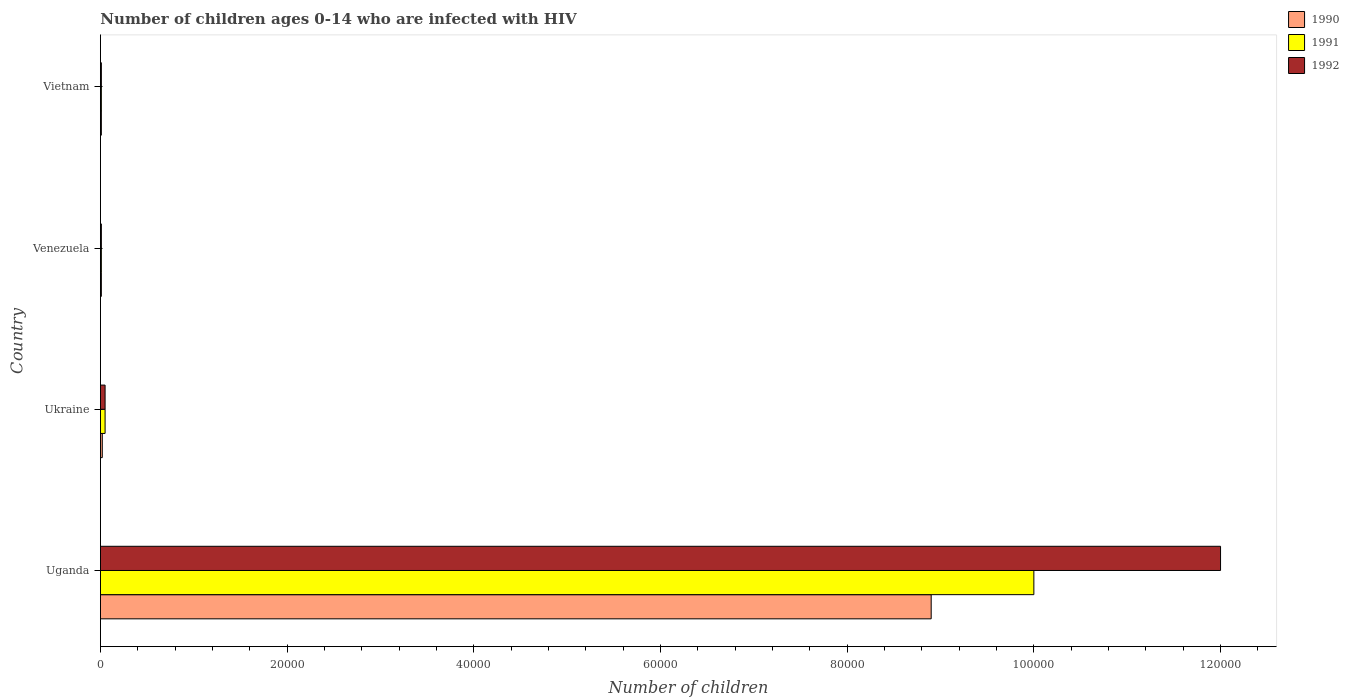How many different coloured bars are there?
Offer a very short reply. 3. Are the number of bars per tick equal to the number of legend labels?
Your response must be concise. Yes. Are the number of bars on each tick of the Y-axis equal?
Offer a very short reply. Yes. How many bars are there on the 3rd tick from the top?
Offer a very short reply. 3. What is the label of the 4th group of bars from the top?
Your answer should be compact. Uganda. What is the number of HIV infected children in 1991 in Ukraine?
Give a very brief answer. 500. Across all countries, what is the maximum number of HIV infected children in 1990?
Offer a terse response. 8.90e+04. Across all countries, what is the minimum number of HIV infected children in 1990?
Provide a short and direct response. 100. In which country was the number of HIV infected children in 1990 maximum?
Your response must be concise. Uganda. In which country was the number of HIV infected children in 1992 minimum?
Your response must be concise. Venezuela. What is the total number of HIV infected children in 1992 in the graph?
Offer a terse response. 1.21e+05. What is the difference between the number of HIV infected children in 1990 in Uganda and that in Ukraine?
Your answer should be compact. 8.88e+04. What is the difference between the number of HIV infected children in 1992 in Uganda and the number of HIV infected children in 1990 in Ukraine?
Offer a very short reply. 1.20e+05. What is the average number of HIV infected children in 1991 per country?
Make the answer very short. 2.52e+04. What is the difference between the number of HIV infected children in 1992 and number of HIV infected children in 1990 in Venezuela?
Make the answer very short. 0. In how many countries, is the number of HIV infected children in 1990 greater than 80000 ?
Offer a terse response. 1. What is the ratio of the number of HIV infected children in 1991 in Uganda to that in Ukraine?
Make the answer very short. 200. Is the number of HIV infected children in 1991 in Uganda less than that in Vietnam?
Your answer should be very brief. No. What is the difference between the highest and the second highest number of HIV infected children in 1992?
Ensure brevity in your answer.  1.20e+05. What is the difference between the highest and the lowest number of HIV infected children in 1990?
Keep it short and to the point. 8.89e+04. In how many countries, is the number of HIV infected children in 1991 greater than the average number of HIV infected children in 1991 taken over all countries?
Your answer should be very brief. 1. What does the 3rd bar from the top in Vietnam represents?
Your answer should be compact. 1990. What does the 3rd bar from the bottom in Venezuela represents?
Make the answer very short. 1992. Is it the case that in every country, the sum of the number of HIV infected children in 1992 and number of HIV infected children in 1991 is greater than the number of HIV infected children in 1990?
Your answer should be very brief. Yes. How many bars are there?
Your response must be concise. 12. Are all the bars in the graph horizontal?
Offer a terse response. Yes. How many countries are there in the graph?
Provide a succinct answer. 4. What is the difference between two consecutive major ticks on the X-axis?
Ensure brevity in your answer.  2.00e+04. Does the graph contain any zero values?
Offer a terse response. No. Where does the legend appear in the graph?
Provide a short and direct response. Top right. How many legend labels are there?
Your answer should be very brief. 3. What is the title of the graph?
Give a very brief answer. Number of children ages 0-14 who are infected with HIV. What is the label or title of the X-axis?
Make the answer very short. Number of children. What is the label or title of the Y-axis?
Make the answer very short. Country. What is the Number of children of 1990 in Uganda?
Provide a short and direct response. 8.90e+04. What is the Number of children of 1991 in Uganda?
Give a very brief answer. 1.00e+05. What is the Number of children of 1992 in Uganda?
Your response must be concise. 1.20e+05. What is the Number of children in 1990 in Ukraine?
Ensure brevity in your answer.  200. What is the Number of children in 1992 in Ukraine?
Offer a very short reply. 500. What is the Number of children in 1990 in Venezuela?
Your answer should be very brief. 100. What is the Number of children in 1991 in Venezuela?
Provide a short and direct response. 100. What is the Number of children in 1992 in Vietnam?
Keep it short and to the point. 100. Across all countries, what is the maximum Number of children of 1990?
Your answer should be compact. 8.90e+04. Across all countries, what is the minimum Number of children of 1990?
Offer a very short reply. 100. What is the total Number of children of 1990 in the graph?
Offer a terse response. 8.94e+04. What is the total Number of children in 1991 in the graph?
Your answer should be compact. 1.01e+05. What is the total Number of children of 1992 in the graph?
Provide a succinct answer. 1.21e+05. What is the difference between the Number of children in 1990 in Uganda and that in Ukraine?
Provide a short and direct response. 8.88e+04. What is the difference between the Number of children in 1991 in Uganda and that in Ukraine?
Provide a succinct answer. 9.95e+04. What is the difference between the Number of children of 1992 in Uganda and that in Ukraine?
Keep it short and to the point. 1.20e+05. What is the difference between the Number of children of 1990 in Uganda and that in Venezuela?
Your response must be concise. 8.89e+04. What is the difference between the Number of children in 1991 in Uganda and that in Venezuela?
Make the answer very short. 9.99e+04. What is the difference between the Number of children of 1992 in Uganda and that in Venezuela?
Your answer should be compact. 1.20e+05. What is the difference between the Number of children in 1990 in Uganda and that in Vietnam?
Provide a succinct answer. 8.89e+04. What is the difference between the Number of children of 1991 in Uganda and that in Vietnam?
Ensure brevity in your answer.  9.99e+04. What is the difference between the Number of children of 1992 in Uganda and that in Vietnam?
Provide a short and direct response. 1.20e+05. What is the difference between the Number of children of 1992 in Ukraine and that in Venezuela?
Offer a terse response. 400. What is the difference between the Number of children of 1992 in Ukraine and that in Vietnam?
Make the answer very short. 400. What is the difference between the Number of children of 1990 in Venezuela and that in Vietnam?
Make the answer very short. 0. What is the difference between the Number of children of 1992 in Venezuela and that in Vietnam?
Provide a succinct answer. 0. What is the difference between the Number of children of 1990 in Uganda and the Number of children of 1991 in Ukraine?
Your response must be concise. 8.85e+04. What is the difference between the Number of children in 1990 in Uganda and the Number of children in 1992 in Ukraine?
Your answer should be compact. 8.85e+04. What is the difference between the Number of children of 1991 in Uganda and the Number of children of 1992 in Ukraine?
Your answer should be very brief. 9.95e+04. What is the difference between the Number of children in 1990 in Uganda and the Number of children in 1991 in Venezuela?
Offer a very short reply. 8.89e+04. What is the difference between the Number of children of 1990 in Uganda and the Number of children of 1992 in Venezuela?
Keep it short and to the point. 8.89e+04. What is the difference between the Number of children of 1991 in Uganda and the Number of children of 1992 in Venezuela?
Offer a very short reply. 9.99e+04. What is the difference between the Number of children in 1990 in Uganda and the Number of children in 1991 in Vietnam?
Ensure brevity in your answer.  8.89e+04. What is the difference between the Number of children of 1990 in Uganda and the Number of children of 1992 in Vietnam?
Your answer should be compact. 8.89e+04. What is the difference between the Number of children in 1991 in Uganda and the Number of children in 1992 in Vietnam?
Make the answer very short. 9.99e+04. What is the difference between the Number of children of 1990 in Ukraine and the Number of children of 1991 in Venezuela?
Offer a terse response. 100. What is the difference between the Number of children in 1990 in Ukraine and the Number of children in 1991 in Vietnam?
Offer a terse response. 100. What is the difference between the Number of children in 1991 in Ukraine and the Number of children in 1992 in Vietnam?
Your answer should be very brief. 400. What is the difference between the Number of children of 1990 in Venezuela and the Number of children of 1991 in Vietnam?
Provide a short and direct response. 0. What is the average Number of children of 1990 per country?
Provide a short and direct response. 2.24e+04. What is the average Number of children in 1991 per country?
Provide a succinct answer. 2.52e+04. What is the average Number of children of 1992 per country?
Give a very brief answer. 3.02e+04. What is the difference between the Number of children in 1990 and Number of children in 1991 in Uganda?
Keep it short and to the point. -1.10e+04. What is the difference between the Number of children of 1990 and Number of children of 1992 in Uganda?
Offer a terse response. -3.10e+04. What is the difference between the Number of children of 1990 and Number of children of 1991 in Ukraine?
Keep it short and to the point. -300. What is the difference between the Number of children in 1990 and Number of children in 1992 in Ukraine?
Offer a very short reply. -300. What is the difference between the Number of children in 1990 and Number of children in 1991 in Vietnam?
Your response must be concise. 0. What is the difference between the Number of children in 1990 and Number of children in 1992 in Vietnam?
Offer a very short reply. 0. What is the ratio of the Number of children in 1990 in Uganda to that in Ukraine?
Provide a short and direct response. 445. What is the ratio of the Number of children of 1992 in Uganda to that in Ukraine?
Offer a very short reply. 240. What is the ratio of the Number of children of 1990 in Uganda to that in Venezuela?
Provide a succinct answer. 890. What is the ratio of the Number of children in 1991 in Uganda to that in Venezuela?
Keep it short and to the point. 1000. What is the ratio of the Number of children in 1992 in Uganda to that in Venezuela?
Ensure brevity in your answer.  1200. What is the ratio of the Number of children of 1990 in Uganda to that in Vietnam?
Offer a very short reply. 890. What is the ratio of the Number of children of 1991 in Uganda to that in Vietnam?
Your response must be concise. 1000. What is the ratio of the Number of children in 1992 in Uganda to that in Vietnam?
Keep it short and to the point. 1200. What is the ratio of the Number of children of 1991 in Ukraine to that in Venezuela?
Keep it short and to the point. 5. What is the ratio of the Number of children in 1992 in Ukraine to that in Venezuela?
Provide a succinct answer. 5. What is the ratio of the Number of children in 1990 in Ukraine to that in Vietnam?
Your answer should be compact. 2. What is the ratio of the Number of children of 1991 in Venezuela to that in Vietnam?
Give a very brief answer. 1. What is the ratio of the Number of children of 1992 in Venezuela to that in Vietnam?
Offer a terse response. 1. What is the difference between the highest and the second highest Number of children in 1990?
Provide a succinct answer. 8.88e+04. What is the difference between the highest and the second highest Number of children in 1991?
Make the answer very short. 9.95e+04. What is the difference between the highest and the second highest Number of children of 1992?
Offer a very short reply. 1.20e+05. What is the difference between the highest and the lowest Number of children in 1990?
Your answer should be very brief. 8.89e+04. What is the difference between the highest and the lowest Number of children of 1991?
Provide a succinct answer. 9.99e+04. What is the difference between the highest and the lowest Number of children in 1992?
Give a very brief answer. 1.20e+05. 